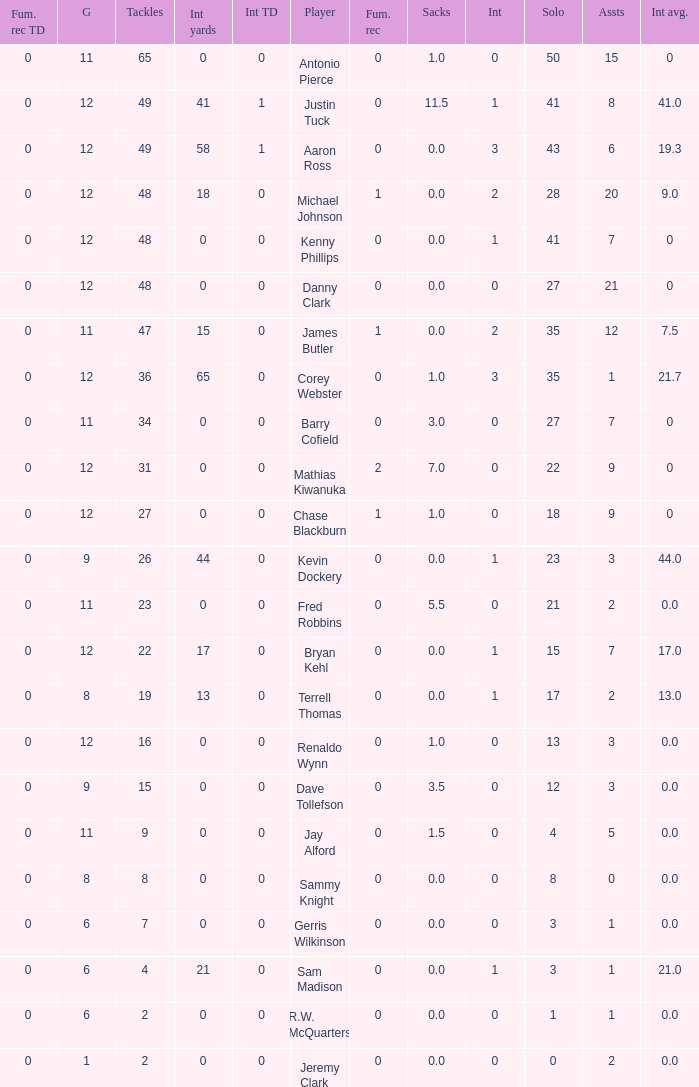Name the least int yards when sacks is 11.5 41.0. 